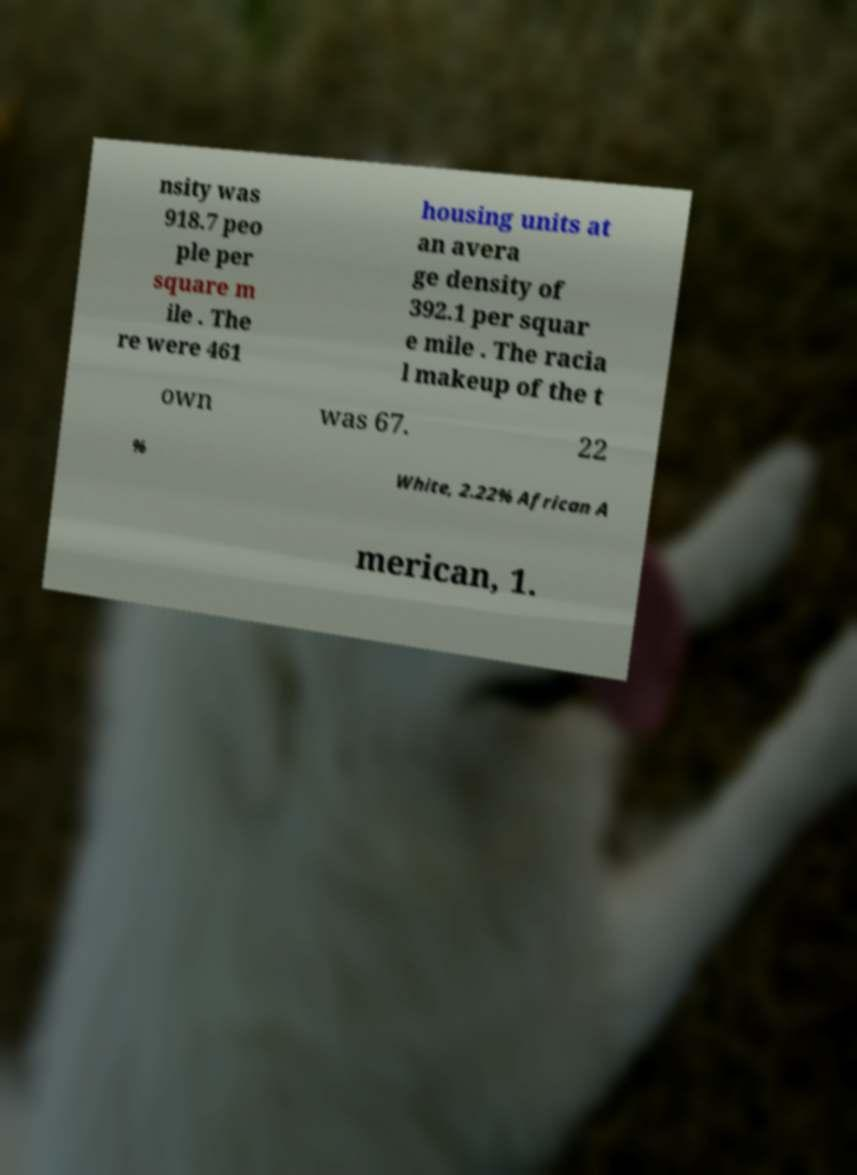For documentation purposes, I need the text within this image transcribed. Could you provide that? nsity was 918.7 peo ple per square m ile . The re were 461 housing units at an avera ge density of 392.1 per squar e mile . The racia l makeup of the t own was 67. 22 % White, 2.22% African A merican, 1. 